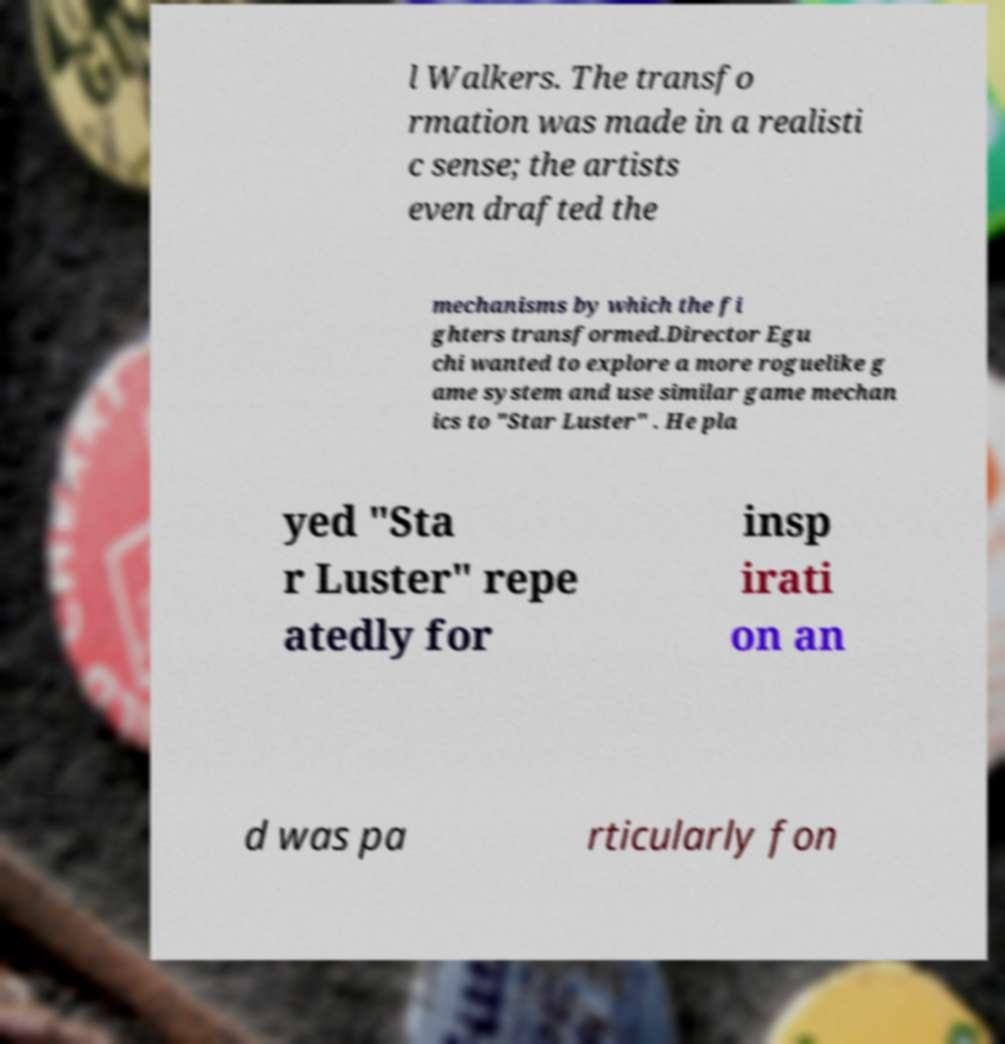Please read and relay the text visible in this image. What does it say? l Walkers. The transfo rmation was made in a realisti c sense; the artists even drafted the mechanisms by which the fi ghters transformed.Director Egu chi wanted to explore a more roguelike g ame system and use similar game mechan ics to "Star Luster" . He pla yed "Sta r Luster" repe atedly for insp irati on an d was pa rticularly fon 